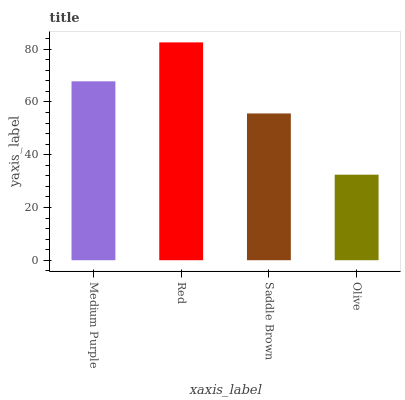Is Olive the minimum?
Answer yes or no. Yes. Is Red the maximum?
Answer yes or no. Yes. Is Saddle Brown the minimum?
Answer yes or no. No. Is Saddle Brown the maximum?
Answer yes or no. No. Is Red greater than Saddle Brown?
Answer yes or no. Yes. Is Saddle Brown less than Red?
Answer yes or no. Yes. Is Saddle Brown greater than Red?
Answer yes or no. No. Is Red less than Saddle Brown?
Answer yes or no. No. Is Medium Purple the high median?
Answer yes or no. Yes. Is Saddle Brown the low median?
Answer yes or no. Yes. Is Olive the high median?
Answer yes or no. No. Is Olive the low median?
Answer yes or no. No. 